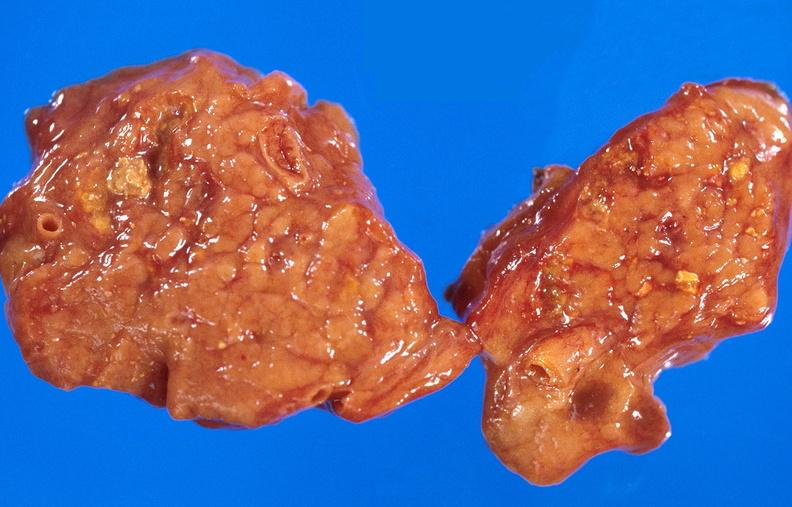does this image show pancreatic fat necrosis?
Answer the question using a single word or phrase. Yes 